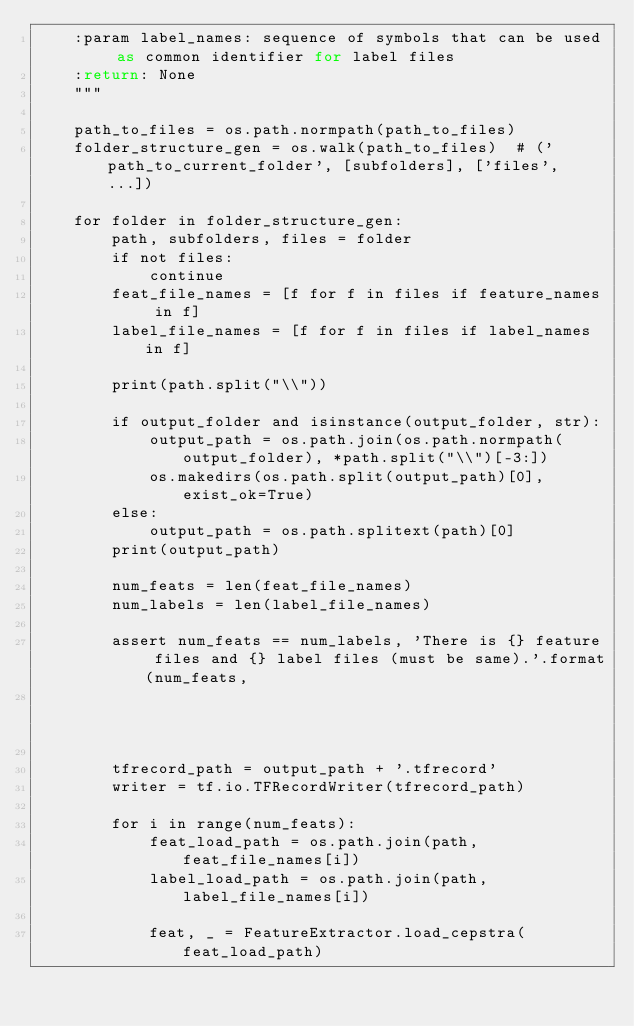Convert code to text. <code><loc_0><loc_0><loc_500><loc_500><_Python_>    :param label_names: sequence of symbols that can be used as common identifier for label files
    :return: None
    """

    path_to_files = os.path.normpath(path_to_files)
    folder_structure_gen = os.walk(path_to_files)  # ('path_to_current_folder', [subfolders], ['files', ...])

    for folder in folder_structure_gen:
        path, subfolders, files = folder
        if not files:
            continue
        feat_file_names = [f for f in files if feature_names in f]
        label_file_names = [f for f in files if label_names in f]

        print(path.split("\\"))

        if output_folder and isinstance(output_folder, str):
            output_path = os.path.join(os.path.normpath(output_folder), *path.split("\\")[-3:])
            os.makedirs(os.path.split(output_path)[0], exist_ok=True)
        else:
            output_path = os.path.splitext(path)[0]
        print(output_path)

        num_feats = len(feat_file_names)
        num_labels = len(label_file_names)

        assert num_feats == num_labels, 'There is {} feature files and {} label files (must be same).'.format(num_feats,
                                                                                                              num_labels)

        tfrecord_path = output_path + '.tfrecord'
        writer = tf.io.TFRecordWriter(tfrecord_path)

        for i in range(num_feats):
            feat_load_path = os.path.join(path, feat_file_names[i])
            label_load_path = os.path.join(path, label_file_names[i])

            feat, _ = FeatureExtractor.load_cepstra(feat_load_path)</code> 